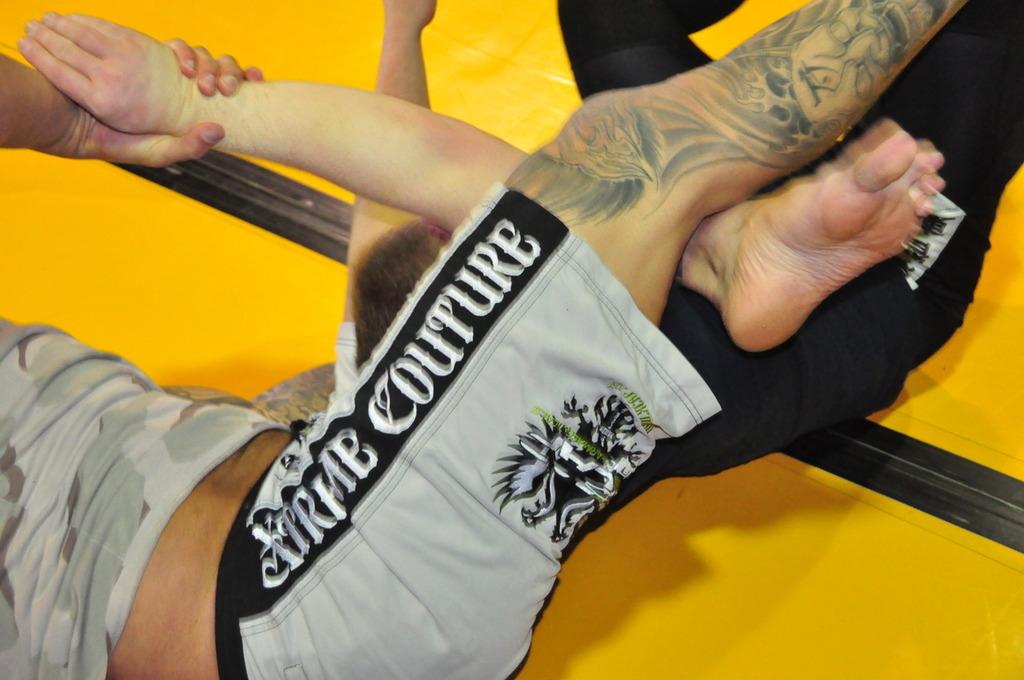What is the last name of the wrestler wearing gray shorts?
Provide a succinct answer. Unanswerable. 